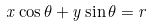<formula> <loc_0><loc_0><loc_500><loc_500>x \cos \theta + y \sin \theta = r</formula> 